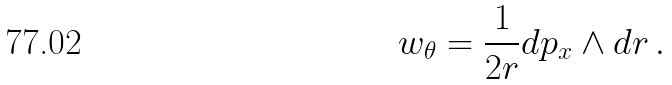Convert formula to latex. <formula><loc_0><loc_0><loc_500><loc_500>w _ { \theta } = \frac { 1 } { 2 r } d p _ { x } \wedge d r \, .</formula> 